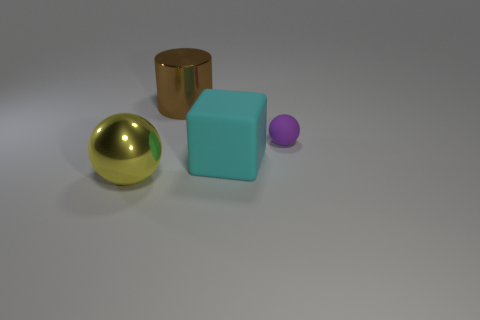There is a brown metal thing that is the same size as the yellow metal thing; what is its shape?
Ensure brevity in your answer.  Cylinder. What number of objects are either brown cylinders that are left of the tiny object or tiny blue blocks?
Make the answer very short. 1. There is a ball on the right side of the yellow thing; how big is it?
Offer a very short reply. Small. Are there any matte blocks of the same size as the cyan rubber thing?
Your answer should be very brief. No. Does the shiny object that is in front of the rubber block have the same size as the big matte block?
Offer a very short reply. Yes. How big is the brown cylinder?
Keep it short and to the point. Large. The ball right of the shiny thing that is behind the sphere that is to the right of the large brown cylinder is what color?
Your answer should be compact. Purple. How many objects are both on the right side of the cyan cube and behind the tiny purple rubber thing?
Offer a very short reply. 0. What is the size of the other thing that is the same shape as the big yellow metal object?
Provide a succinct answer. Small. How many big things are on the right side of the big shiny object that is behind the big shiny object in front of the cylinder?
Offer a very short reply. 1. 